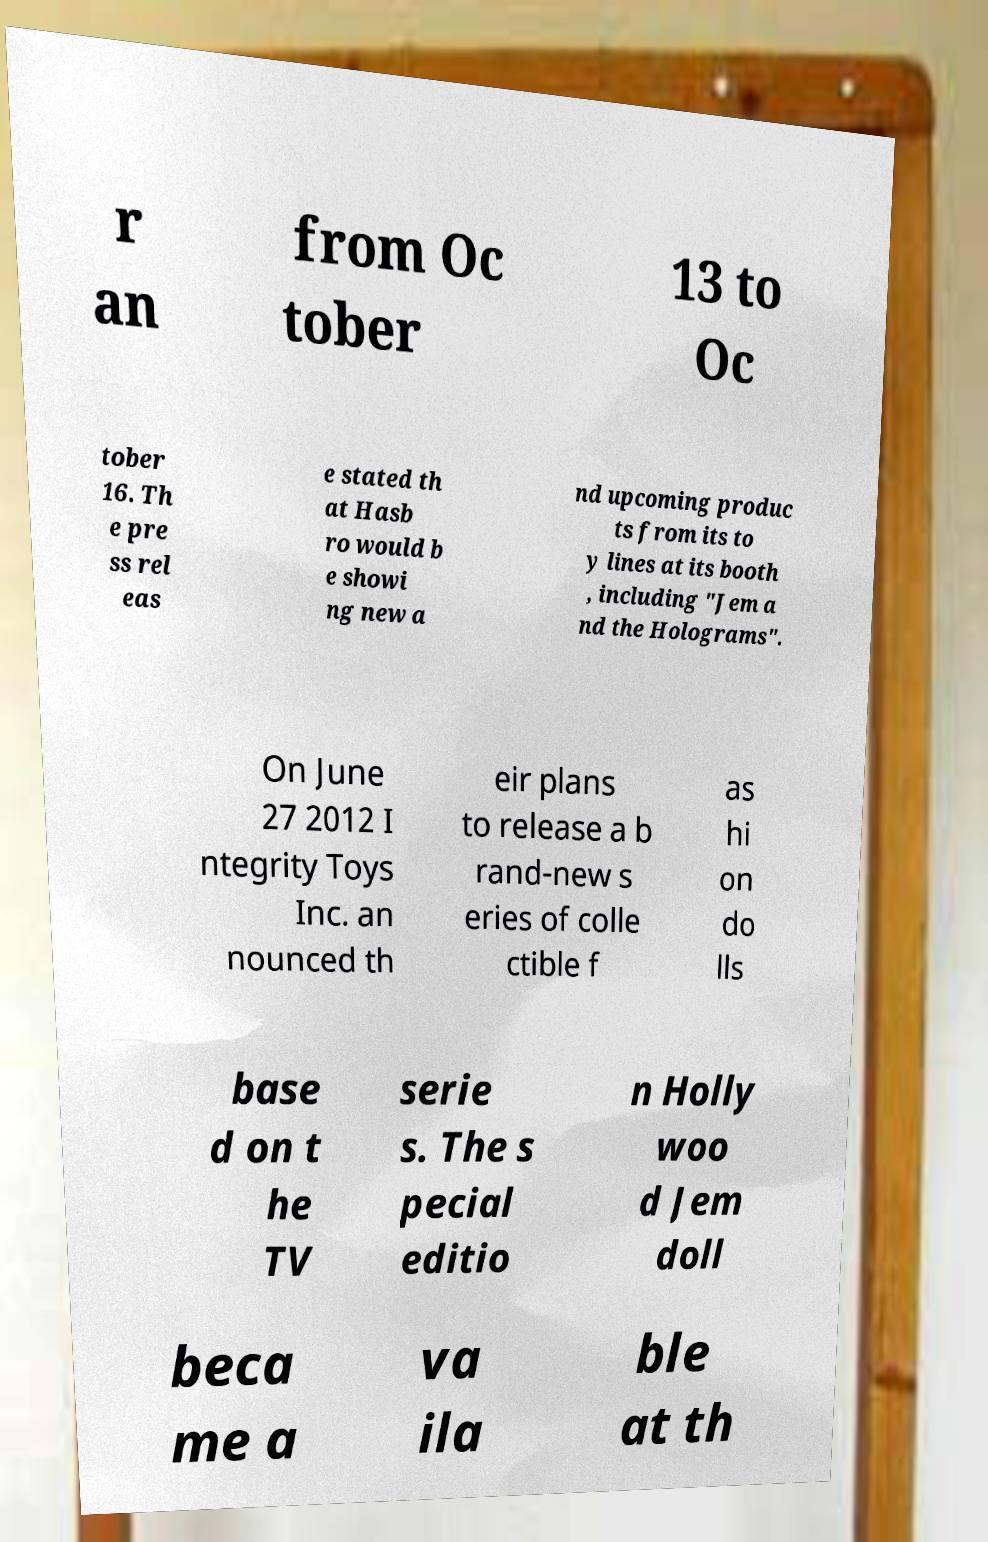There's text embedded in this image that I need extracted. Can you transcribe it verbatim? r an from Oc tober 13 to Oc tober 16. Th e pre ss rel eas e stated th at Hasb ro would b e showi ng new a nd upcoming produc ts from its to y lines at its booth , including "Jem a nd the Holograms". On June 27 2012 I ntegrity Toys Inc. an nounced th eir plans to release a b rand-new s eries of colle ctible f as hi on do lls base d on t he TV serie s. The s pecial editio n Holly woo d Jem doll beca me a va ila ble at th 